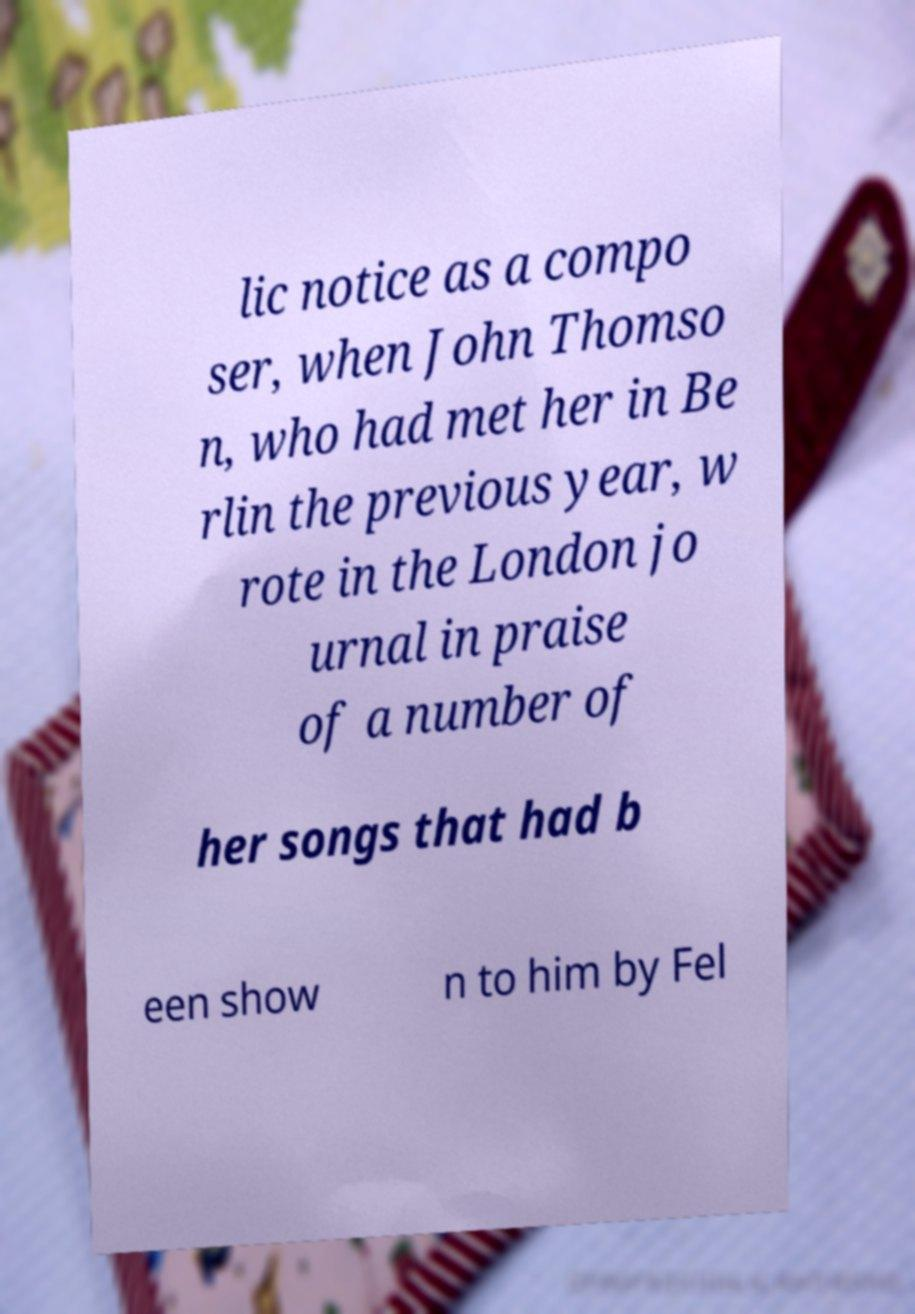What messages or text are displayed in this image? I need them in a readable, typed format. lic notice as a compo ser, when John Thomso n, who had met her in Be rlin the previous year, w rote in the London jo urnal in praise of a number of her songs that had b een show n to him by Fel 